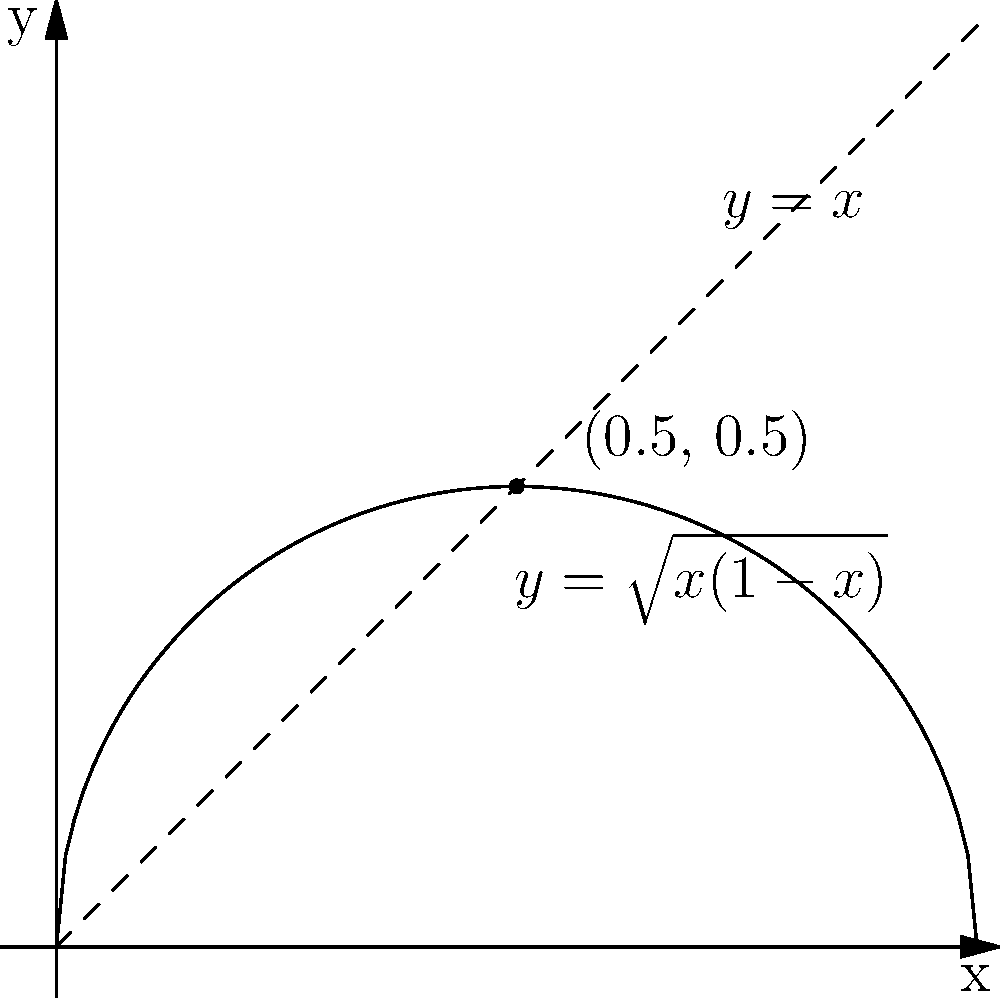In the 18th century, French naval architects were experimenting with sail shapes to optimize ship speed. They modeled the sail curve as $y = \sqrt{x(1-x)}$ for $0 \leq x \leq 1$, where $x$ and $y$ are normalized dimensions. What is the maximum height of the sail, and at what $x$-coordinate does it occur? To find the maximum height of the sail, we need to find the maximum value of the function $f(x) = \sqrt{x(1-x)}$ on the interval $[0,1]$.

Step 1: Take the derivative of $f(x)$.
$$f'(x) = \frac{1-2x}{2\sqrt{x(1-x)}}$$

Step 2: Set $f'(x) = 0$ and solve for $x$.
$$\frac{1-2x}{2\sqrt{x(1-x)}} = 0$$
$$1-2x = 0$$
$$x = \frac{1}{2}$$

Step 3: Verify this is a maximum by checking the second derivative or endpoints.
The second derivative is negative at $x=\frac{1}{2}$, confirming a maximum.

Step 4: Calculate the maximum height by plugging $x=\frac{1}{2}$ into the original function.
$$f(\frac{1}{2}) = \sqrt{\frac{1}{2}(1-\frac{1}{2})} = \sqrt{\frac{1}{4}} = \frac{1}{2}$$

Therefore, the maximum height occurs at $x=\frac{1}{2}$ and the height is $\frac{1}{2}$.
Answer: Maximum height: $\frac{1}{2}$ at $x=\frac{1}{2}$ 